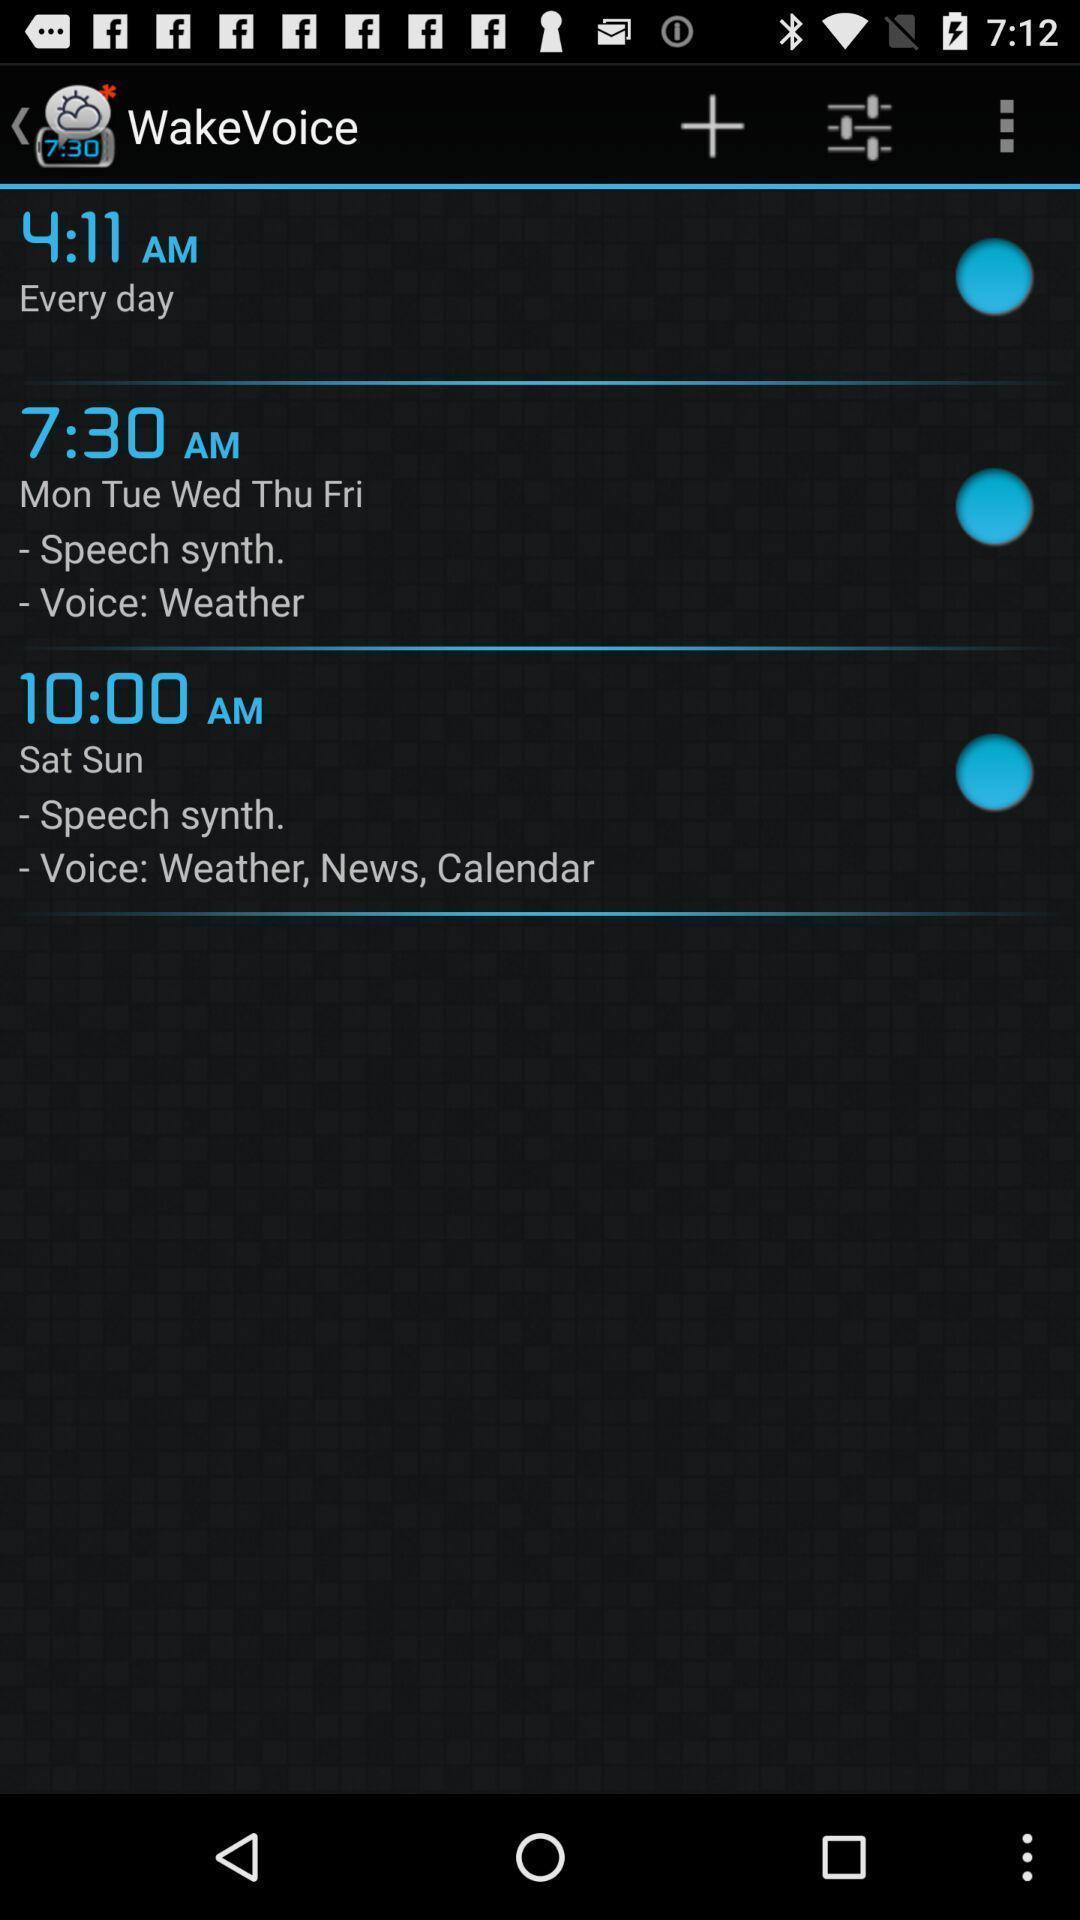Please provide a description for this image. Screen shows a timer in a device. 